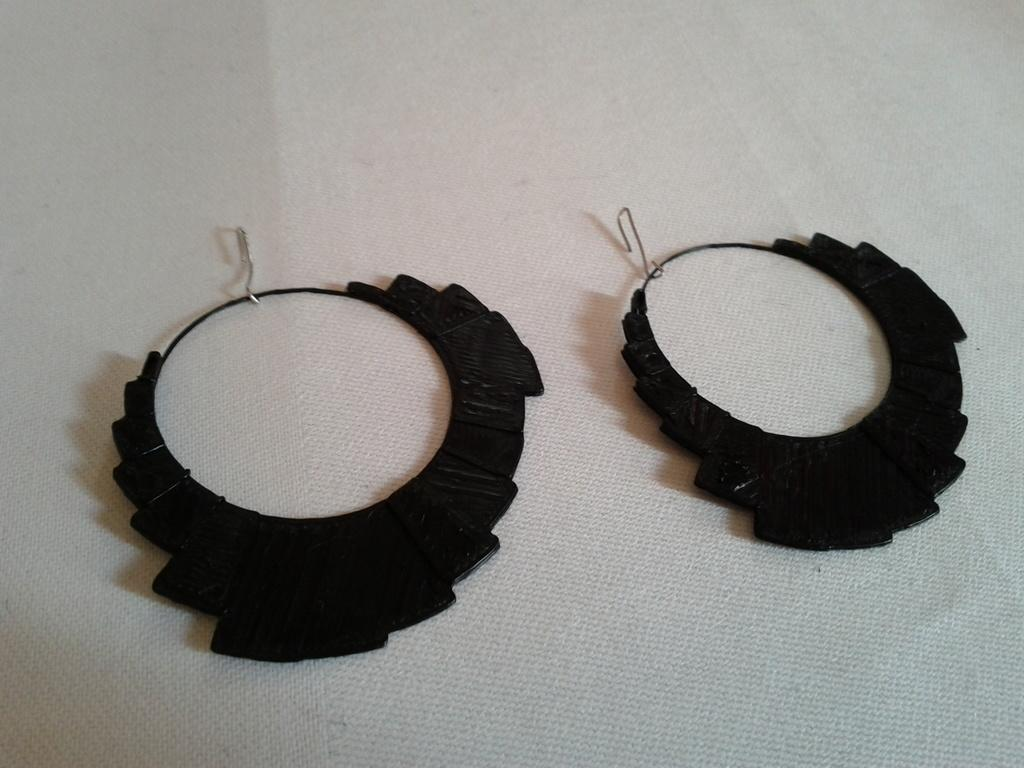What type of jewelry is visible in the image? There are earrings in the image. Where are the earrings placed in the image? The earrings are on a white platform. What type of laborer is present in the image? There is no laborer present in the image. --- Facts: 1. There is a person in the image. 2. The person is wearing a hat. 3. The person is holding a book. 4. The book has a title on the cover. 5. The background of the image is a park. Absurd Topics: elephant, piano Conversation: What is the main subject in the image? There is a person in the image. What is the person wearing in the image? The person is wearing a hat. What is the person holding in the image? The person is holding a book. What can be seen on the cover of the book? The book has a title on the cover. What can be seen in the background of the image? The background of the image is a park. Reasoning: Let's think step by step in order to produce the conversation. We start by identifying the main subject of the image, which is the person. Next, we describe specific features of the person, such as the hat. Then, we observe the actions of the person, noting that they are holding a book. After that, we describe the background of the image, which is a park. Absurd Question/Answer: What type of elephant can be seen playing the piano in the image? There is no elephant, let alone one playing the piano, present in the image. --- Facts: 1. There is a cat in the image. 2. The cat is sitting on a windowsill. 3. The windowsill has a red cushion. 4. The cat is looking out the window. 5. The background of the image is a cityscape. Absurd Topics: giraffe, trampoline Conversation: What type of animal is visible in the image? There is a cat in the image. Where is the cat located in the image? The cat is sitting on a windowsill. What is on the windowsill? The windowsill has a red cushion. What is the cat doing in the image? The cat is looking out the window. What can be seen in the background of the image? The background of the image is a cityscape. Reasoning: Let's think step by step in order to produce the conversation. We start by identifying the main subject of the image, which is the cat. Next, we describe the location of the cat, noting that they are sitting on a windowsill. Then, we observe the actions of the cat, noting that they are looking out the window. After that, we describe the windowsill, mentioning the red cushion. Finally, we describe the background of the image, which 